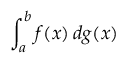<formula> <loc_0><loc_0><loc_500><loc_500>\int _ { a } ^ { b } f ( x ) \, d g ( x )</formula> 